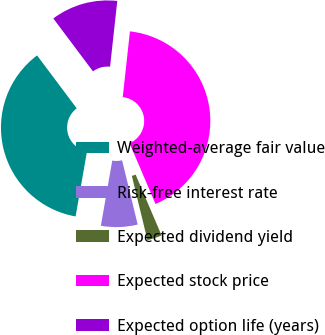Convert chart. <chart><loc_0><loc_0><loc_500><loc_500><pie_chart><fcel>Weighted-average fair value<fcel>Risk-free interest rate<fcel>Expected dividend yield<fcel>Expected stock price<fcel>Expected option life (years)<nl><fcel>37.0%<fcel>6.55%<fcel>2.63%<fcel>41.84%<fcel>11.98%<nl></chart> 